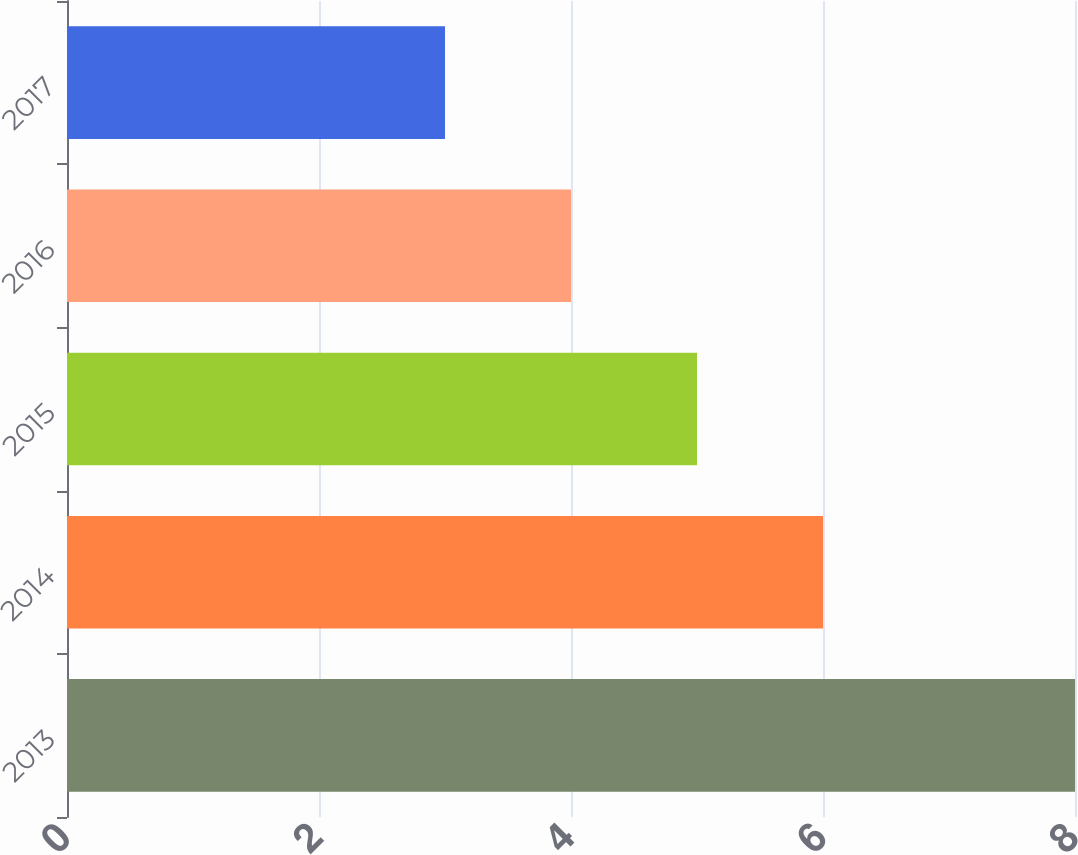Convert chart to OTSL. <chart><loc_0><loc_0><loc_500><loc_500><bar_chart><fcel>2013<fcel>2014<fcel>2015<fcel>2016<fcel>2017<nl><fcel>8<fcel>6<fcel>5<fcel>4<fcel>3<nl></chart> 